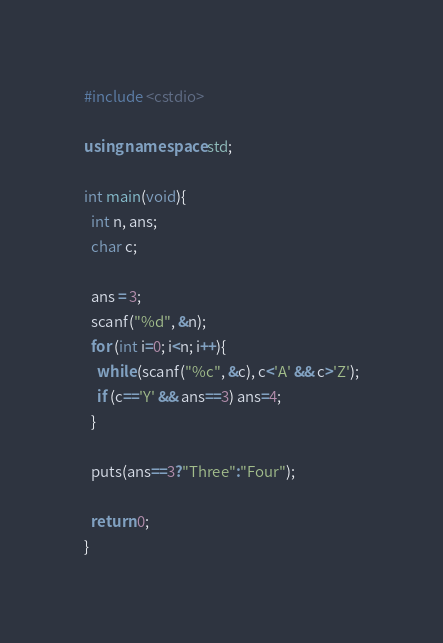<code> <loc_0><loc_0><loc_500><loc_500><_C++_>#include <cstdio>

using namespace std;

int main(void){
  int n, ans;
  char c;
  
  ans = 3;
  scanf("%d", &n);
  for (int i=0; i<n; i++){
    while (scanf("%c", &c), c<'A' && c>'Z');
    if (c=='Y' && ans==3) ans=4;
  }
  
  puts(ans==3?"Three":"Four");
  
  return 0;
}</code> 